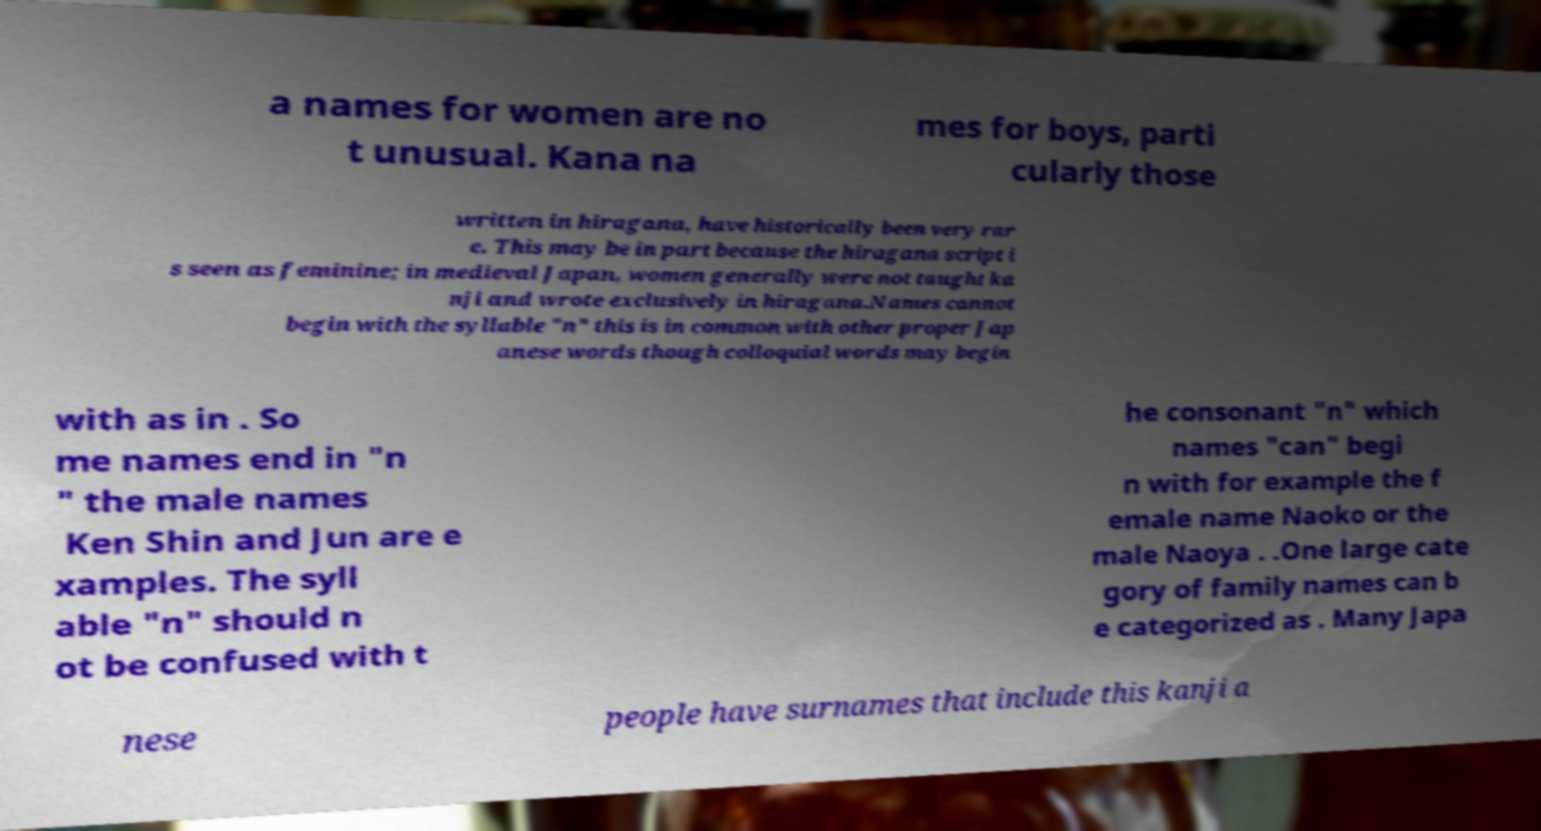I need the written content from this picture converted into text. Can you do that? a names for women are no t unusual. Kana na mes for boys, parti cularly those written in hiragana, have historically been very rar e. This may be in part because the hiragana script i s seen as feminine; in medieval Japan, women generally were not taught ka nji and wrote exclusively in hiragana.Names cannot begin with the syllable "n" this is in common with other proper Jap anese words though colloquial words may begin with as in . So me names end in "n " the male names Ken Shin and Jun are e xamples. The syll able "n" should n ot be confused with t he consonant "n" which names "can" begi n with for example the f emale name Naoko or the male Naoya . .One large cate gory of family names can b e categorized as . Many Japa nese people have surnames that include this kanji a 